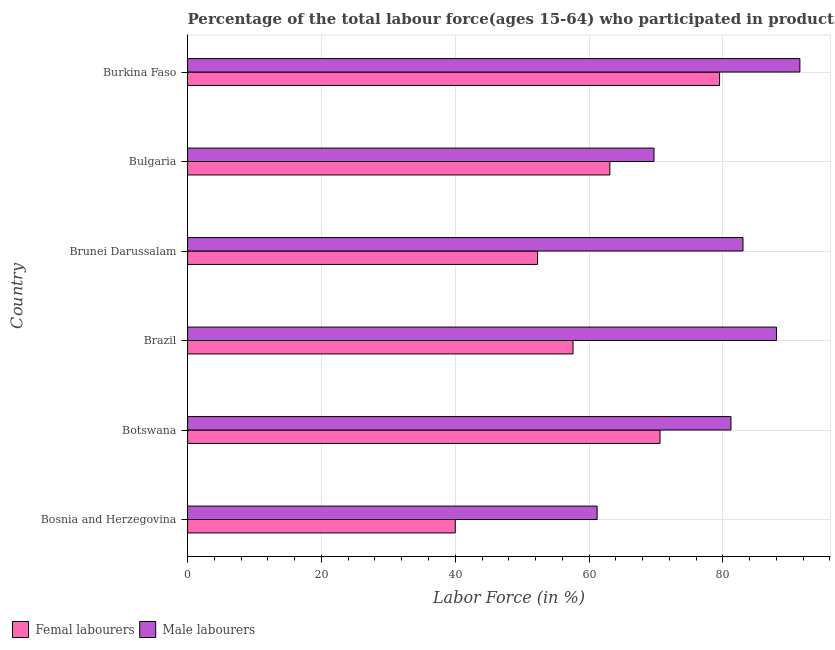How many different coloured bars are there?
Keep it short and to the point. 2. How many groups of bars are there?
Offer a very short reply. 6. Are the number of bars per tick equal to the number of legend labels?
Your answer should be compact. Yes. Are the number of bars on each tick of the Y-axis equal?
Your answer should be compact. Yes. What is the label of the 2nd group of bars from the top?
Your response must be concise. Bulgaria. In how many cases, is the number of bars for a given country not equal to the number of legend labels?
Your response must be concise. 0. What is the percentage of female labor force in Bulgaria?
Keep it short and to the point. 63.1. Across all countries, what is the maximum percentage of female labor force?
Offer a very short reply. 79.5. In which country was the percentage of male labour force maximum?
Provide a short and direct response. Burkina Faso. In which country was the percentage of male labour force minimum?
Provide a short and direct response. Bosnia and Herzegovina. What is the total percentage of female labor force in the graph?
Your response must be concise. 363.1. What is the difference between the percentage of male labour force in Brazil and that in Burkina Faso?
Make the answer very short. -3.5. What is the difference between the percentage of female labor force in Bosnia and Herzegovina and the percentage of male labour force in Brunei Darussalam?
Provide a succinct answer. -43. What is the average percentage of male labour force per country?
Provide a short and direct response. 79.1. What is the difference between the percentage of female labor force and percentage of male labour force in Brazil?
Provide a succinct answer. -30.4. In how many countries, is the percentage of male labour force greater than 88 %?
Provide a succinct answer. 1. What is the ratio of the percentage of male labour force in Botswana to that in Bulgaria?
Keep it short and to the point. 1.17. Is the percentage of female labor force in Botswana less than that in Bulgaria?
Ensure brevity in your answer.  No. What is the difference between the highest and the lowest percentage of female labor force?
Offer a very short reply. 39.5. In how many countries, is the percentage of male labour force greater than the average percentage of male labour force taken over all countries?
Provide a succinct answer. 4. What does the 1st bar from the top in Burkina Faso represents?
Keep it short and to the point. Male labourers. What does the 2nd bar from the bottom in Bulgaria represents?
Give a very brief answer. Male labourers. How many countries are there in the graph?
Keep it short and to the point. 6. What is the difference between two consecutive major ticks on the X-axis?
Offer a terse response. 20. Does the graph contain any zero values?
Keep it short and to the point. No. How many legend labels are there?
Offer a terse response. 2. What is the title of the graph?
Your answer should be compact. Percentage of the total labour force(ages 15-64) who participated in production in 1995. What is the label or title of the Y-axis?
Ensure brevity in your answer.  Country. What is the Labor Force (in %) of Femal labourers in Bosnia and Herzegovina?
Provide a succinct answer. 40. What is the Labor Force (in %) of Male labourers in Bosnia and Herzegovina?
Your response must be concise. 61.2. What is the Labor Force (in %) in Femal labourers in Botswana?
Ensure brevity in your answer.  70.6. What is the Labor Force (in %) of Male labourers in Botswana?
Make the answer very short. 81.2. What is the Labor Force (in %) in Femal labourers in Brazil?
Offer a terse response. 57.6. What is the Labor Force (in %) in Male labourers in Brazil?
Offer a very short reply. 88. What is the Labor Force (in %) in Femal labourers in Brunei Darussalam?
Your answer should be compact. 52.3. What is the Labor Force (in %) of Male labourers in Brunei Darussalam?
Offer a terse response. 83. What is the Labor Force (in %) of Femal labourers in Bulgaria?
Your response must be concise. 63.1. What is the Labor Force (in %) of Male labourers in Bulgaria?
Provide a short and direct response. 69.7. What is the Labor Force (in %) of Femal labourers in Burkina Faso?
Make the answer very short. 79.5. What is the Labor Force (in %) in Male labourers in Burkina Faso?
Make the answer very short. 91.5. Across all countries, what is the maximum Labor Force (in %) in Femal labourers?
Your answer should be very brief. 79.5. Across all countries, what is the maximum Labor Force (in %) in Male labourers?
Offer a very short reply. 91.5. Across all countries, what is the minimum Labor Force (in %) of Male labourers?
Keep it short and to the point. 61.2. What is the total Labor Force (in %) in Femal labourers in the graph?
Provide a short and direct response. 363.1. What is the total Labor Force (in %) in Male labourers in the graph?
Ensure brevity in your answer.  474.6. What is the difference between the Labor Force (in %) of Femal labourers in Bosnia and Herzegovina and that in Botswana?
Offer a terse response. -30.6. What is the difference between the Labor Force (in %) in Male labourers in Bosnia and Herzegovina and that in Botswana?
Make the answer very short. -20. What is the difference between the Labor Force (in %) of Femal labourers in Bosnia and Herzegovina and that in Brazil?
Your response must be concise. -17.6. What is the difference between the Labor Force (in %) of Male labourers in Bosnia and Herzegovina and that in Brazil?
Provide a succinct answer. -26.8. What is the difference between the Labor Force (in %) of Male labourers in Bosnia and Herzegovina and that in Brunei Darussalam?
Your response must be concise. -21.8. What is the difference between the Labor Force (in %) of Femal labourers in Bosnia and Herzegovina and that in Bulgaria?
Provide a short and direct response. -23.1. What is the difference between the Labor Force (in %) of Male labourers in Bosnia and Herzegovina and that in Bulgaria?
Give a very brief answer. -8.5. What is the difference between the Labor Force (in %) of Femal labourers in Bosnia and Herzegovina and that in Burkina Faso?
Your response must be concise. -39.5. What is the difference between the Labor Force (in %) of Male labourers in Bosnia and Herzegovina and that in Burkina Faso?
Provide a succinct answer. -30.3. What is the difference between the Labor Force (in %) in Femal labourers in Botswana and that in Brazil?
Offer a terse response. 13. What is the difference between the Labor Force (in %) in Femal labourers in Botswana and that in Bulgaria?
Give a very brief answer. 7.5. What is the difference between the Labor Force (in %) of Male labourers in Botswana and that in Burkina Faso?
Keep it short and to the point. -10.3. What is the difference between the Labor Force (in %) in Femal labourers in Brazil and that in Brunei Darussalam?
Ensure brevity in your answer.  5.3. What is the difference between the Labor Force (in %) of Femal labourers in Brazil and that in Bulgaria?
Give a very brief answer. -5.5. What is the difference between the Labor Force (in %) in Femal labourers in Brazil and that in Burkina Faso?
Ensure brevity in your answer.  -21.9. What is the difference between the Labor Force (in %) in Femal labourers in Brunei Darussalam and that in Burkina Faso?
Offer a terse response. -27.2. What is the difference between the Labor Force (in %) in Femal labourers in Bulgaria and that in Burkina Faso?
Make the answer very short. -16.4. What is the difference between the Labor Force (in %) in Male labourers in Bulgaria and that in Burkina Faso?
Your answer should be very brief. -21.8. What is the difference between the Labor Force (in %) in Femal labourers in Bosnia and Herzegovina and the Labor Force (in %) in Male labourers in Botswana?
Your answer should be compact. -41.2. What is the difference between the Labor Force (in %) in Femal labourers in Bosnia and Herzegovina and the Labor Force (in %) in Male labourers in Brazil?
Provide a succinct answer. -48. What is the difference between the Labor Force (in %) of Femal labourers in Bosnia and Herzegovina and the Labor Force (in %) of Male labourers in Brunei Darussalam?
Offer a very short reply. -43. What is the difference between the Labor Force (in %) in Femal labourers in Bosnia and Herzegovina and the Labor Force (in %) in Male labourers in Bulgaria?
Offer a very short reply. -29.7. What is the difference between the Labor Force (in %) in Femal labourers in Bosnia and Herzegovina and the Labor Force (in %) in Male labourers in Burkina Faso?
Make the answer very short. -51.5. What is the difference between the Labor Force (in %) of Femal labourers in Botswana and the Labor Force (in %) of Male labourers in Brazil?
Provide a short and direct response. -17.4. What is the difference between the Labor Force (in %) in Femal labourers in Botswana and the Labor Force (in %) in Male labourers in Bulgaria?
Your response must be concise. 0.9. What is the difference between the Labor Force (in %) in Femal labourers in Botswana and the Labor Force (in %) in Male labourers in Burkina Faso?
Offer a very short reply. -20.9. What is the difference between the Labor Force (in %) of Femal labourers in Brazil and the Labor Force (in %) of Male labourers in Brunei Darussalam?
Your answer should be compact. -25.4. What is the difference between the Labor Force (in %) in Femal labourers in Brazil and the Labor Force (in %) in Male labourers in Bulgaria?
Offer a terse response. -12.1. What is the difference between the Labor Force (in %) in Femal labourers in Brazil and the Labor Force (in %) in Male labourers in Burkina Faso?
Your answer should be very brief. -33.9. What is the difference between the Labor Force (in %) in Femal labourers in Brunei Darussalam and the Labor Force (in %) in Male labourers in Bulgaria?
Your answer should be very brief. -17.4. What is the difference between the Labor Force (in %) of Femal labourers in Brunei Darussalam and the Labor Force (in %) of Male labourers in Burkina Faso?
Your answer should be compact. -39.2. What is the difference between the Labor Force (in %) of Femal labourers in Bulgaria and the Labor Force (in %) of Male labourers in Burkina Faso?
Provide a short and direct response. -28.4. What is the average Labor Force (in %) of Femal labourers per country?
Give a very brief answer. 60.52. What is the average Labor Force (in %) in Male labourers per country?
Ensure brevity in your answer.  79.1. What is the difference between the Labor Force (in %) in Femal labourers and Labor Force (in %) in Male labourers in Bosnia and Herzegovina?
Offer a terse response. -21.2. What is the difference between the Labor Force (in %) in Femal labourers and Labor Force (in %) in Male labourers in Botswana?
Make the answer very short. -10.6. What is the difference between the Labor Force (in %) in Femal labourers and Labor Force (in %) in Male labourers in Brazil?
Your answer should be compact. -30.4. What is the difference between the Labor Force (in %) of Femal labourers and Labor Force (in %) of Male labourers in Brunei Darussalam?
Your answer should be compact. -30.7. What is the difference between the Labor Force (in %) of Femal labourers and Labor Force (in %) of Male labourers in Bulgaria?
Offer a terse response. -6.6. What is the ratio of the Labor Force (in %) in Femal labourers in Bosnia and Herzegovina to that in Botswana?
Offer a very short reply. 0.57. What is the ratio of the Labor Force (in %) in Male labourers in Bosnia and Herzegovina to that in Botswana?
Make the answer very short. 0.75. What is the ratio of the Labor Force (in %) in Femal labourers in Bosnia and Herzegovina to that in Brazil?
Provide a short and direct response. 0.69. What is the ratio of the Labor Force (in %) of Male labourers in Bosnia and Herzegovina to that in Brazil?
Your answer should be compact. 0.7. What is the ratio of the Labor Force (in %) of Femal labourers in Bosnia and Herzegovina to that in Brunei Darussalam?
Keep it short and to the point. 0.76. What is the ratio of the Labor Force (in %) of Male labourers in Bosnia and Herzegovina to that in Brunei Darussalam?
Give a very brief answer. 0.74. What is the ratio of the Labor Force (in %) of Femal labourers in Bosnia and Herzegovina to that in Bulgaria?
Offer a terse response. 0.63. What is the ratio of the Labor Force (in %) in Male labourers in Bosnia and Herzegovina to that in Bulgaria?
Your answer should be compact. 0.88. What is the ratio of the Labor Force (in %) in Femal labourers in Bosnia and Herzegovina to that in Burkina Faso?
Ensure brevity in your answer.  0.5. What is the ratio of the Labor Force (in %) in Male labourers in Bosnia and Herzegovina to that in Burkina Faso?
Provide a succinct answer. 0.67. What is the ratio of the Labor Force (in %) in Femal labourers in Botswana to that in Brazil?
Provide a short and direct response. 1.23. What is the ratio of the Labor Force (in %) in Male labourers in Botswana to that in Brazil?
Your answer should be very brief. 0.92. What is the ratio of the Labor Force (in %) in Femal labourers in Botswana to that in Brunei Darussalam?
Provide a succinct answer. 1.35. What is the ratio of the Labor Force (in %) in Male labourers in Botswana to that in Brunei Darussalam?
Ensure brevity in your answer.  0.98. What is the ratio of the Labor Force (in %) of Femal labourers in Botswana to that in Bulgaria?
Provide a short and direct response. 1.12. What is the ratio of the Labor Force (in %) in Male labourers in Botswana to that in Bulgaria?
Ensure brevity in your answer.  1.17. What is the ratio of the Labor Force (in %) in Femal labourers in Botswana to that in Burkina Faso?
Make the answer very short. 0.89. What is the ratio of the Labor Force (in %) in Male labourers in Botswana to that in Burkina Faso?
Your answer should be compact. 0.89. What is the ratio of the Labor Force (in %) in Femal labourers in Brazil to that in Brunei Darussalam?
Provide a short and direct response. 1.1. What is the ratio of the Labor Force (in %) in Male labourers in Brazil to that in Brunei Darussalam?
Offer a very short reply. 1.06. What is the ratio of the Labor Force (in %) of Femal labourers in Brazil to that in Bulgaria?
Keep it short and to the point. 0.91. What is the ratio of the Labor Force (in %) in Male labourers in Brazil to that in Bulgaria?
Offer a very short reply. 1.26. What is the ratio of the Labor Force (in %) in Femal labourers in Brazil to that in Burkina Faso?
Offer a terse response. 0.72. What is the ratio of the Labor Force (in %) in Male labourers in Brazil to that in Burkina Faso?
Give a very brief answer. 0.96. What is the ratio of the Labor Force (in %) in Femal labourers in Brunei Darussalam to that in Bulgaria?
Ensure brevity in your answer.  0.83. What is the ratio of the Labor Force (in %) in Male labourers in Brunei Darussalam to that in Bulgaria?
Provide a short and direct response. 1.19. What is the ratio of the Labor Force (in %) of Femal labourers in Brunei Darussalam to that in Burkina Faso?
Keep it short and to the point. 0.66. What is the ratio of the Labor Force (in %) of Male labourers in Brunei Darussalam to that in Burkina Faso?
Your answer should be compact. 0.91. What is the ratio of the Labor Force (in %) in Femal labourers in Bulgaria to that in Burkina Faso?
Your answer should be very brief. 0.79. What is the ratio of the Labor Force (in %) in Male labourers in Bulgaria to that in Burkina Faso?
Offer a terse response. 0.76. What is the difference between the highest and the lowest Labor Force (in %) of Femal labourers?
Offer a terse response. 39.5. What is the difference between the highest and the lowest Labor Force (in %) of Male labourers?
Your answer should be compact. 30.3. 